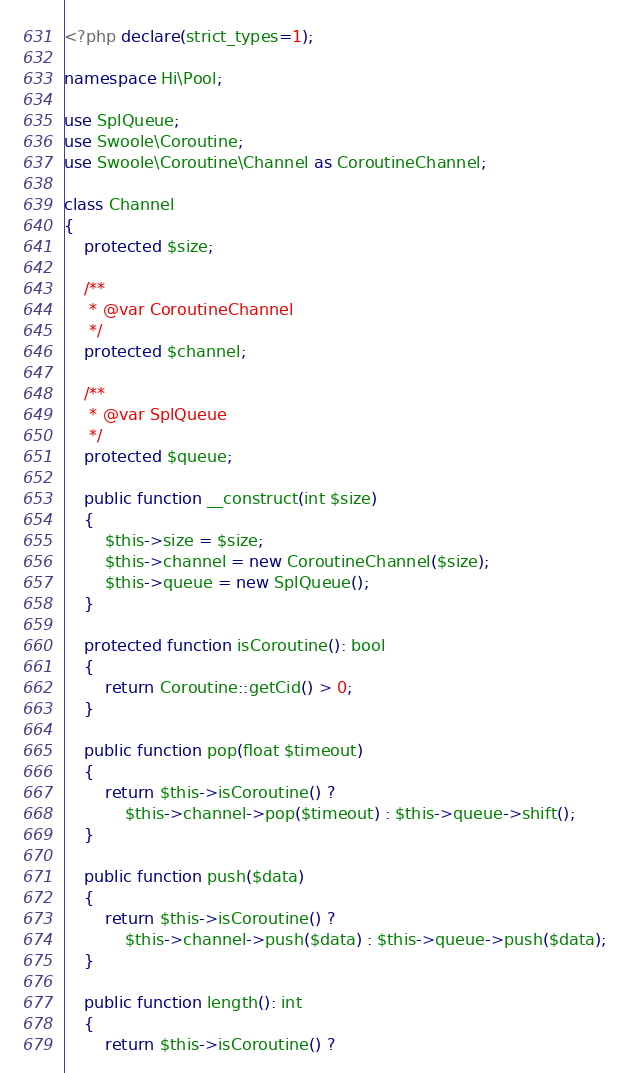Convert code to text. <code><loc_0><loc_0><loc_500><loc_500><_PHP_><?php declare(strict_types=1);

namespace Hi\Pool;

use SplQueue;
use Swoole\Coroutine;
use Swoole\Coroutine\Channel as CoroutineChannel;

class Channel
{
    protected $size;

    /**
     * @var CoroutineChannel
     */
    protected $channel;

    /**
     * @var SplQueue
     */
    protected $queue;

    public function __construct(int $size)
    {
        $this->size = $size;
        $this->channel = new CoroutineChannel($size);
        $this->queue = new SplQueue();
    }

    protected function isCoroutine(): bool
    {
        return Coroutine::getCid() > 0;
    }

    public function pop(float $timeout)
    {
        return $this->isCoroutine() ? 
            $this->channel->pop($timeout) : $this->queue->shift();
    }

    public function push($data)
    {
        return $this->isCoroutine() ?
            $this->channel->push($data) : $this->queue->push($data);
    }

    public function length(): int
    {
        return $this->isCoroutine() ?</code> 